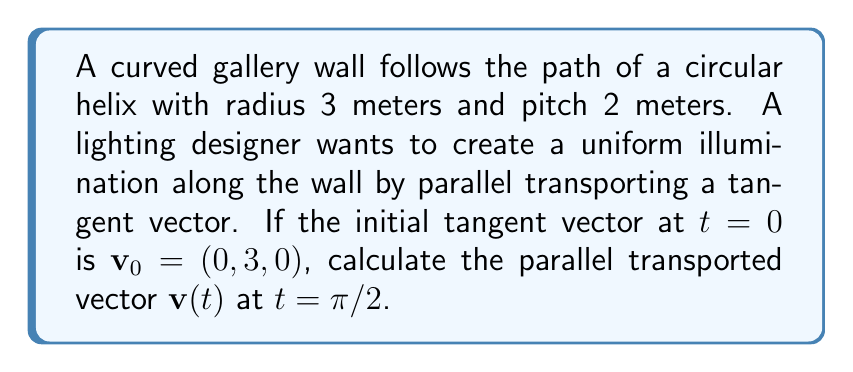Give your solution to this math problem. 1) The parametric equation of a circular helix is:
   $$\mathbf{r}(t) = (a\cos t, a\sin t, bt)$$
   where $a$ is the radius and $2\pi b$ is the pitch. Here, $a=3$ and $b=1/\pi$.

2) The tangent vector $\mathbf{T}(t)$ is:
   $$\mathbf{T}(t) = (-a\sin t, a\cos t, b) = (-3\sin t, 3\cos t, 1/\pi)$$

3) The normal vector $\mathbf{N}(t)$ is:
   $$\mathbf{N}(t) = (-\cos t, -\sin t, 0)$$

4) The binormal vector $\mathbf{B}(t)$ is:
   $$\mathbf{B}(t) = (-\sin t/\pi, \cos t/\pi, -3/\pi)$$

5) The Frenet-Serret formulas for parallel transport are:
   $$\frac{d\mathbf{v}}{dt} = -(\mathbf{v} \cdot \mathbf{N})\kappa\mathbf{T} - (\mathbf{v} \cdot \mathbf{B})\tau\mathbf{N}$$
   where $\kappa$ is the curvature and $\tau$ is the torsion.

6) For a circular helix:
   $$\kappa = \frac{a}{a^2 + b^2} = \frac{3}{9 + (1/\pi)^2}$$
   $$\tau = \frac{b}{a^2 + b^2} = \frac{1/\pi}{9 + (1/\pi)^2}$$

7) The initial vector $\mathbf{v}_0 = (0, 3, 0)$ can be decomposed as:
   $$\mathbf{v}_0 = 3\mathbf{T}(0) + 0\mathbf{N}(0) + 0\mathbf{B}(0)$$

8) Due to parallel transport, these coefficients remain constant. So at $t = \pi/2$:
   $$\mathbf{v}(\pi/2) = 3\mathbf{T}(\pi/2) + 0\mathbf{N}(\pi/2) + 0\mathbf{B}(\pi/2)$$

9) Substituting $t = \pi/2$ into the expression for $\mathbf{T}(t)$:
   $$\mathbf{v}(\pi/2) = 3(-3, 0, 1/\pi) = (-9, 0, 3/\pi)$$
Answer: $(-9, 0, 3/\pi)$ 